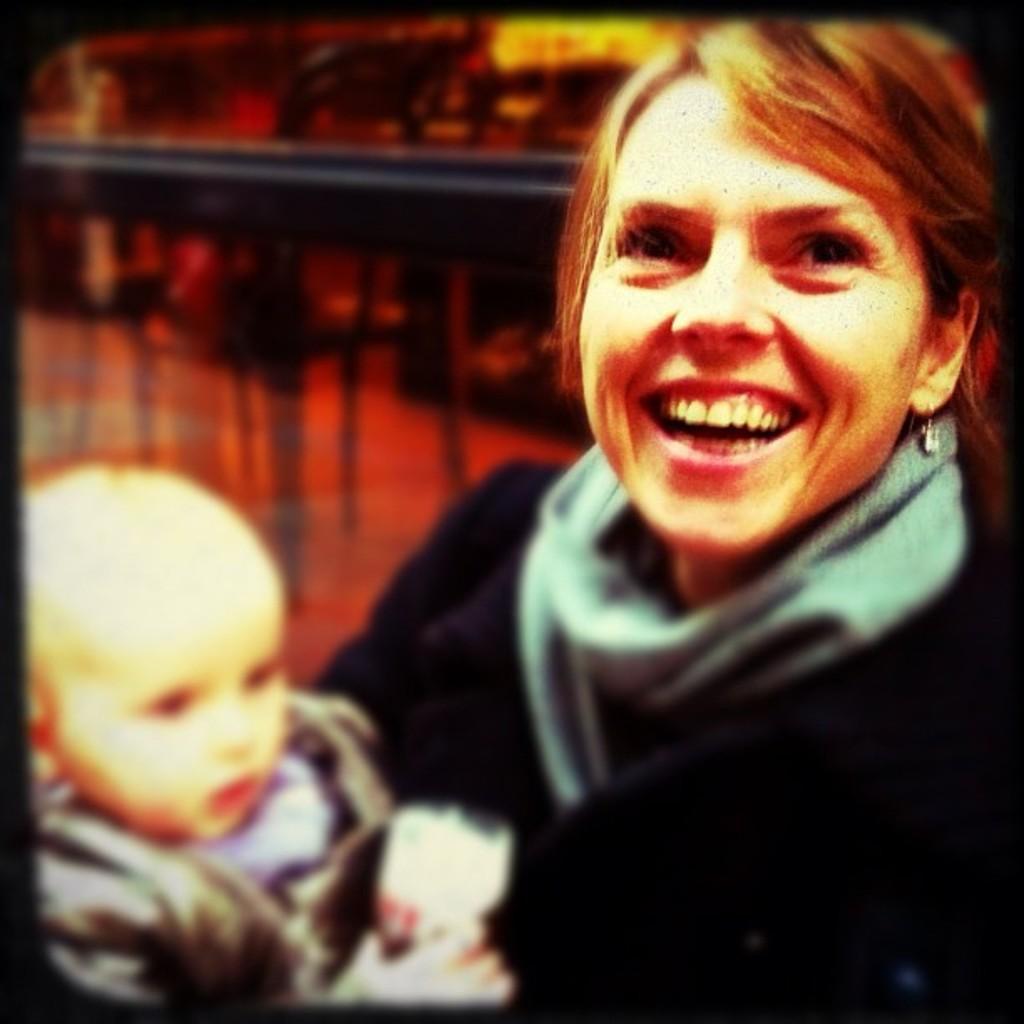How would you summarize this image in a sentence or two? This image is an edited image. This image is taken indoors. In this image the background is a little blurred and there is a railing. In the middle of the image a woman is holding a baby in her hands and she is with a smiling face. 